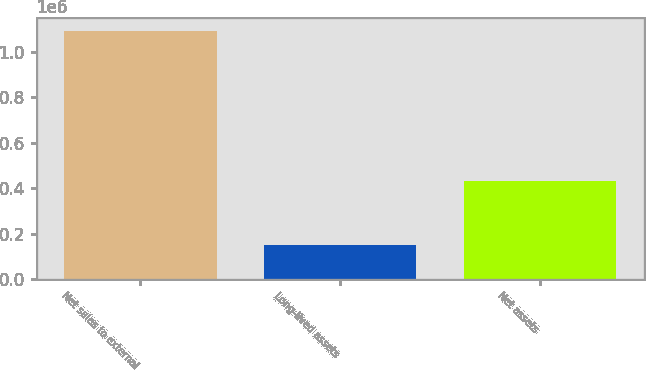<chart> <loc_0><loc_0><loc_500><loc_500><bar_chart><fcel>Net sales to external<fcel>Long-lived assets<fcel>Net assets<nl><fcel>1.09358e+06<fcel>148922<fcel>431795<nl></chart> 